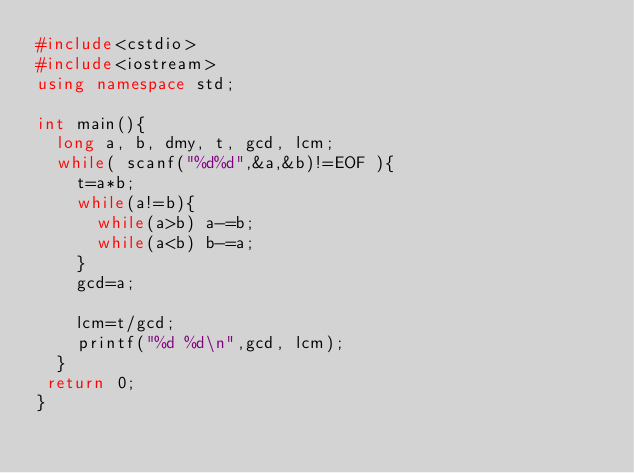<code> <loc_0><loc_0><loc_500><loc_500><_C++_>#include<cstdio>
#include<iostream>
using namespace std;

int main(){
	long a, b, dmy, t, gcd, lcm;
	while( scanf("%d%d",&a,&b)!=EOF ){
		t=a*b;
		while(a!=b){
			while(a>b) a-=b;
			while(a<b) b-=a;
		}
		gcd=a;

		lcm=t/gcd;
		printf("%d %d\n",gcd, lcm);
	}
 return 0;
}</code> 